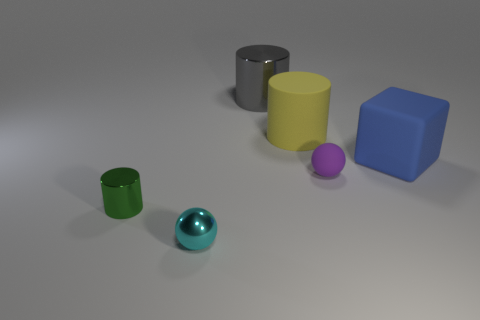There is a small ball that is the same material as the tiny green cylinder; what color is it?
Your answer should be compact. Cyan. How many cyan metal balls are the same size as the matte ball?
Give a very brief answer. 1. What is the material of the blue object?
Give a very brief answer. Rubber. Is the number of tiny cyan matte things greater than the number of metal spheres?
Offer a very short reply. No. Is the big gray thing the same shape as the green metal object?
Provide a short and direct response. Yes. Are there any other things that are the same shape as the blue object?
Offer a very short reply. No. Is the number of objects to the left of the big yellow matte thing less than the number of purple spheres to the right of the tiny purple sphere?
Offer a very short reply. No. What is the shape of the rubber object in front of the large blue thing?
Provide a succinct answer. Sphere. How many other things are the same material as the large yellow cylinder?
Make the answer very short. 2. Do the tiny purple matte object and the small object in front of the green thing have the same shape?
Provide a succinct answer. Yes. 